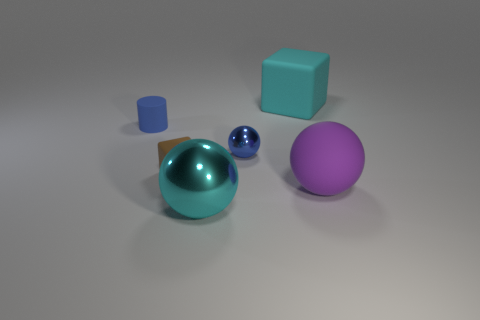Add 1 cyan matte blocks. How many objects exist? 7 Subtract all purple cylinders. Subtract all yellow balls. How many cylinders are left? 1 Subtract all cubes. How many objects are left? 4 Add 4 small matte cubes. How many small matte cubes are left? 5 Add 3 shiny balls. How many shiny balls exist? 5 Subtract 0 green cubes. How many objects are left? 6 Subtract all purple cylinders. Subtract all cyan matte objects. How many objects are left? 5 